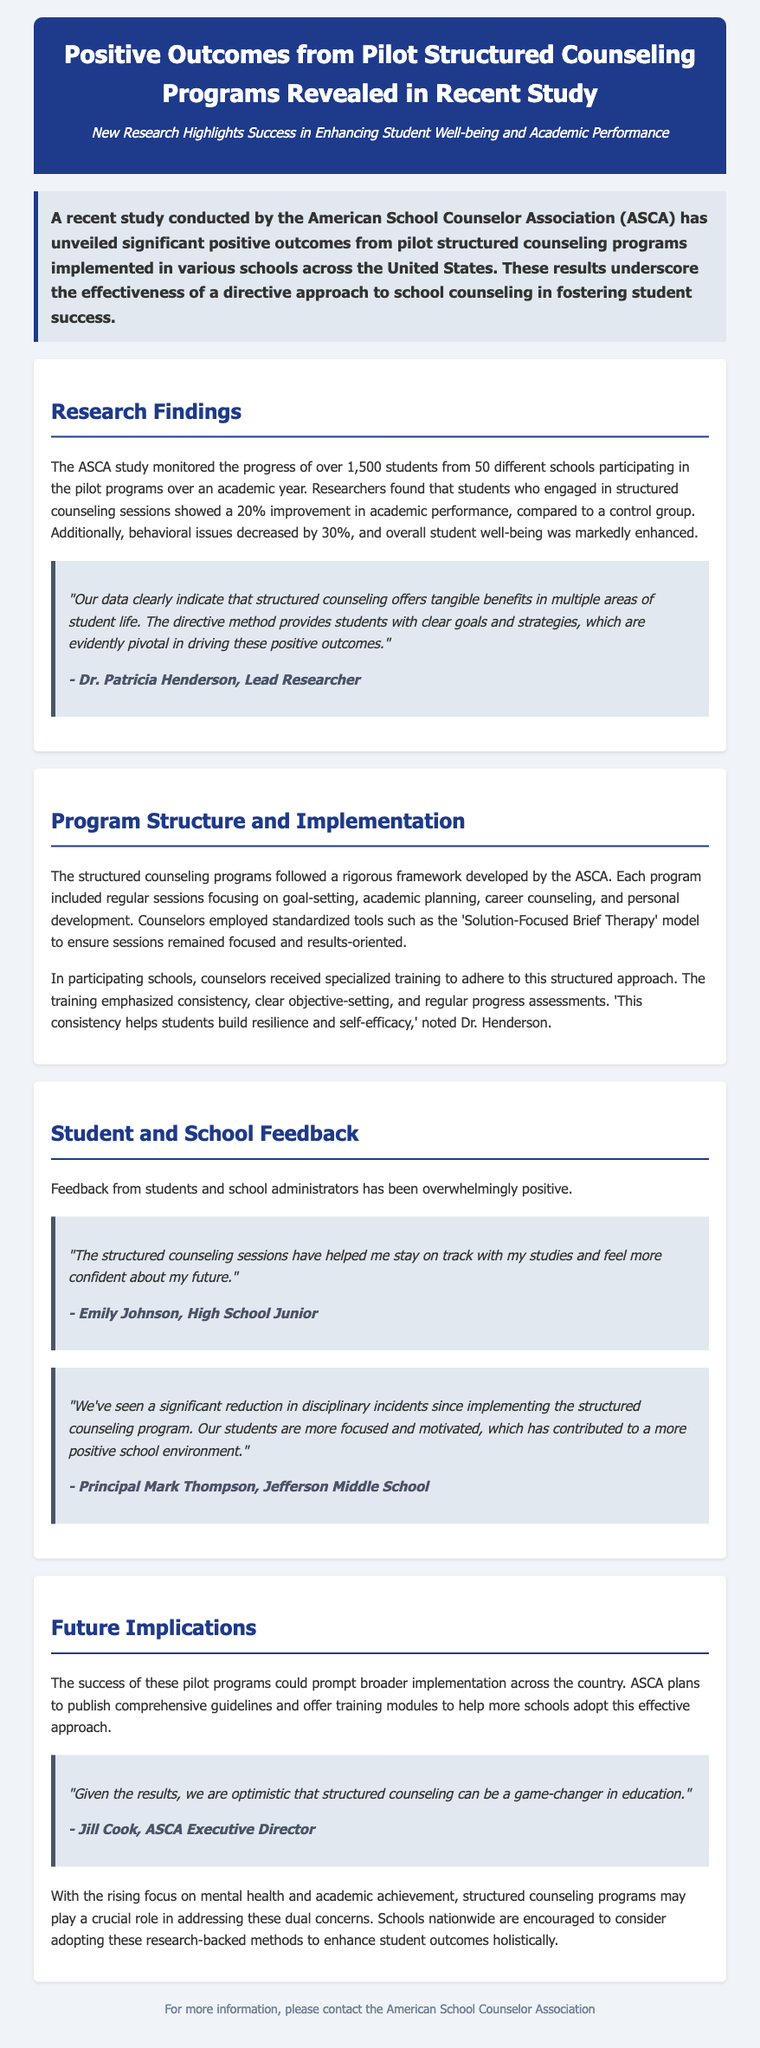What organization conducted the study? The study was conducted by the American School Counselor Association.
Answer: American School Counselor Association How many students were monitored in the study? The study monitored over 1,500 students.
Answer: over 1,500 students What was the percentage improvement in academic performance? Students who engaged in structured counseling sessions showed a 20% improvement.
Answer: 20% What behavioral issue decrease was reported? Behavioral issues decreased by 30%.
Answer: 30% What counseling model was used in the structured programs? Counselors employed the 'Solution-Focused Brief Therapy' model.
Answer: Solution-Focused Brief Therapy Who is the lead researcher mentioned in the document? The lead researcher mentioned is Dr. Patricia Henderson.
Answer: Dr. Patricia Henderson What type of sessions were included in the structured counseling programs? Each program included regular sessions focused on goal-setting, academic planning, career counseling, and personal development.
Answer: goal-setting, academic planning, career counseling, personal development Which principal provided feedback on the structured counseling program? Principal Mark Thompson from Jefferson Middle School provided feedback.
Answer: Principal Mark Thompson What is the position of Jill Cook in relation to ASCA? Jill Cook is the Executive Director of ASCA.
Answer: Executive Director 